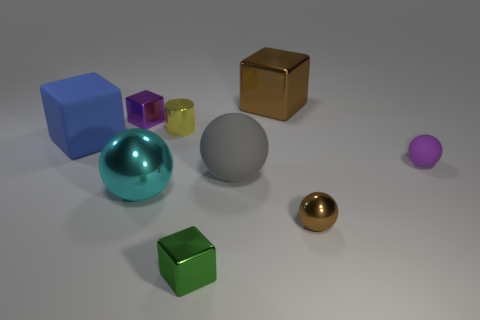Add 1 brown cubes. How many objects exist? 10 Subtract all blocks. How many objects are left? 5 Add 1 small things. How many small things are left? 6 Add 7 gray things. How many gray things exist? 8 Subtract 0 blue cylinders. How many objects are left? 9 Subtract all small brown objects. Subtract all tiny purple spheres. How many objects are left? 7 